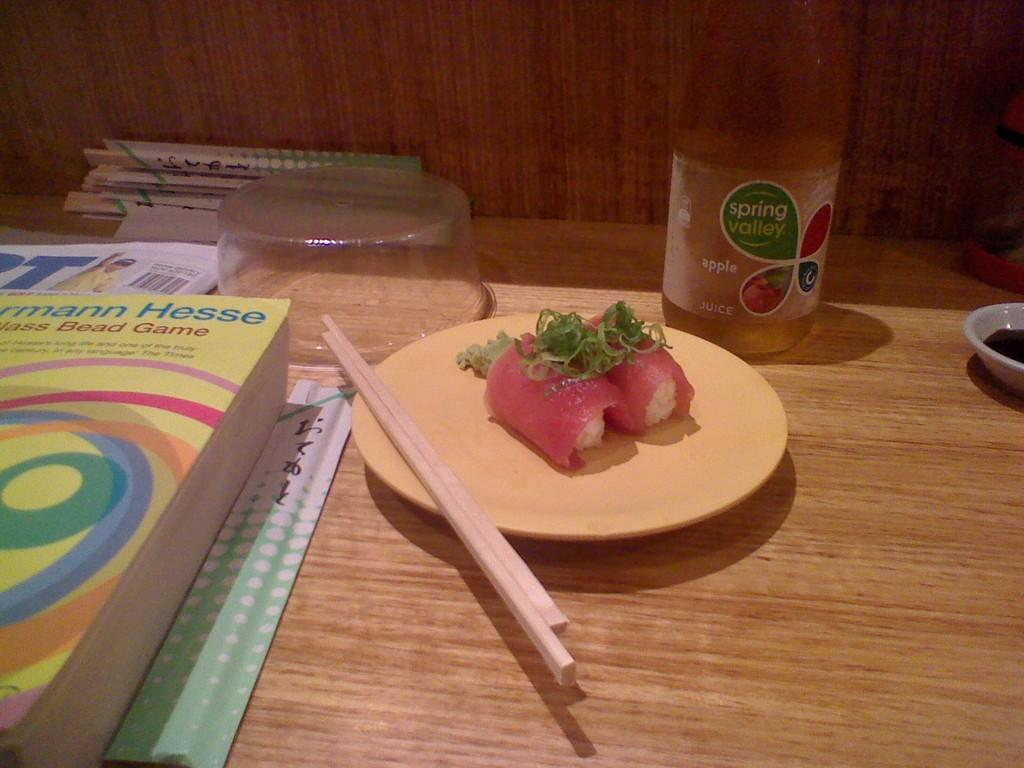<image>
Share a concise interpretation of the image provided. A wood table with a plate of sushi and a bottle of Spring Valley apple juice on it 